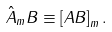Convert formula to latex. <formula><loc_0><loc_0><loc_500><loc_500>\hat { A } _ { m } B \equiv \left [ A B \right ] _ { m } .</formula> 